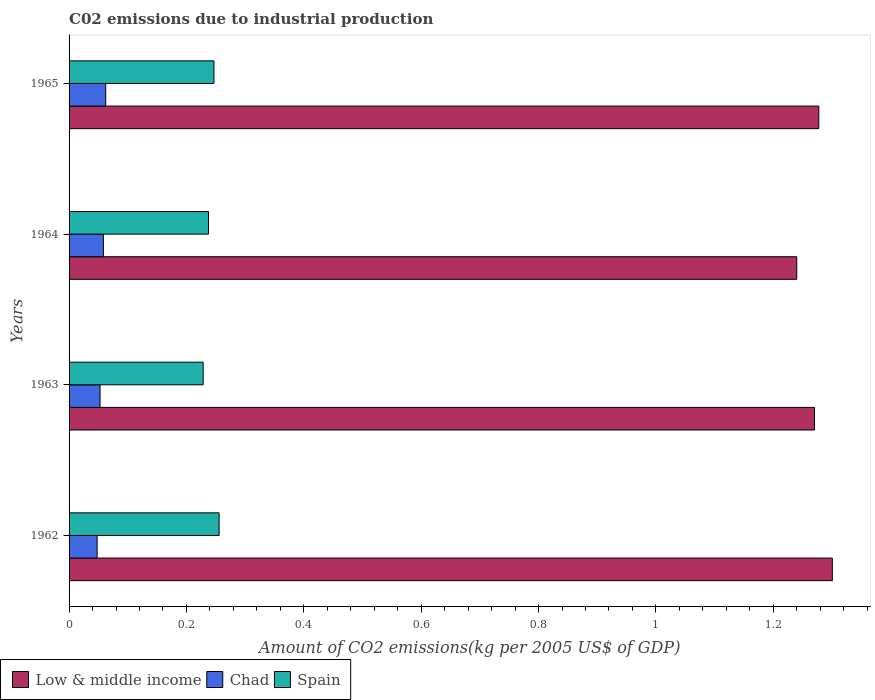How many groups of bars are there?
Offer a terse response. 4. Are the number of bars on each tick of the Y-axis equal?
Ensure brevity in your answer.  Yes. How many bars are there on the 3rd tick from the top?
Provide a short and direct response. 3. In how many cases, is the number of bars for a given year not equal to the number of legend labels?
Provide a short and direct response. 0. What is the amount of CO2 emitted due to industrial production in Chad in 1962?
Your answer should be compact. 0.05. Across all years, what is the maximum amount of CO2 emitted due to industrial production in Spain?
Provide a short and direct response. 0.26. Across all years, what is the minimum amount of CO2 emitted due to industrial production in Chad?
Provide a short and direct response. 0.05. In which year was the amount of CO2 emitted due to industrial production in Chad maximum?
Ensure brevity in your answer.  1965. In which year was the amount of CO2 emitted due to industrial production in Low & middle income minimum?
Offer a very short reply. 1964. What is the total amount of CO2 emitted due to industrial production in Low & middle income in the graph?
Ensure brevity in your answer.  5.09. What is the difference between the amount of CO2 emitted due to industrial production in Low & middle income in 1962 and that in 1963?
Your response must be concise. 0.03. What is the difference between the amount of CO2 emitted due to industrial production in Spain in 1964 and the amount of CO2 emitted due to industrial production in Low & middle income in 1963?
Your response must be concise. -1.03. What is the average amount of CO2 emitted due to industrial production in Low & middle income per year?
Offer a terse response. 1.27. In the year 1965, what is the difference between the amount of CO2 emitted due to industrial production in Low & middle income and amount of CO2 emitted due to industrial production in Spain?
Provide a succinct answer. 1.03. In how many years, is the amount of CO2 emitted due to industrial production in Chad greater than 1.2000000000000002 kg?
Provide a succinct answer. 0. What is the ratio of the amount of CO2 emitted due to industrial production in Low & middle income in 1963 to that in 1964?
Ensure brevity in your answer.  1.02. Is the amount of CO2 emitted due to industrial production in Spain in 1963 less than that in 1964?
Your answer should be very brief. Yes. Is the difference between the amount of CO2 emitted due to industrial production in Low & middle income in 1962 and 1964 greater than the difference between the amount of CO2 emitted due to industrial production in Spain in 1962 and 1964?
Offer a very short reply. Yes. What is the difference between the highest and the second highest amount of CO2 emitted due to industrial production in Chad?
Provide a succinct answer. 0. What is the difference between the highest and the lowest amount of CO2 emitted due to industrial production in Low & middle income?
Ensure brevity in your answer.  0.06. What does the 2nd bar from the top in 1964 represents?
Offer a terse response. Chad. Is it the case that in every year, the sum of the amount of CO2 emitted due to industrial production in Chad and amount of CO2 emitted due to industrial production in Spain is greater than the amount of CO2 emitted due to industrial production in Low & middle income?
Your answer should be very brief. No. Are the values on the major ticks of X-axis written in scientific E-notation?
Provide a short and direct response. No. Does the graph contain any zero values?
Your answer should be compact. No. Where does the legend appear in the graph?
Your answer should be very brief. Bottom left. How many legend labels are there?
Ensure brevity in your answer.  3. How are the legend labels stacked?
Your response must be concise. Horizontal. What is the title of the graph?
Provide a short and direct response. C02 emissions due to industrial production. What is the label or title of the X-axis?
Your answer should be very brief. Amount of CO2 emissions(kg per 2005 US$ of GDP). What is the Amount of CO2 emissions(kg per 2005 US$ of GDP) of Low & middle income in 1962?
Offer a very short reply. 1.3. What is the Amount of CO2 emissions(kg per 2005 US$ of GDP) in Chad in 1962?
Your answer should be compact. 0.05. What is the Amount of CO2 emissions(kg per 2005 US$ of GDP) of Spain in 1962?
Offer a terse response. 0.26. What is the Amount of CO2 emissions(kg per 2005 US$ of GDP) in Low & middle income in 1963?
Keep it short and to the point. 1.27. What is the Amount of CO2 emissions(kg per 2005 US$ of GDP) in Chad in 1963?
Keep it short and to the point. 0.05. What is the Amount of CO2 emissions(kg per 2005 US$ of GDP) in Spain in 1963?
Your answer should be very brief. 0.23. What is the Amount of CO2 emissions(kg per 2005 US$ of GDP) in Low & middle income in 1964?
Offer a very short reply. 1.24. What is the Amount of CO2 emissions(kg per 2005 US$ of GDP) in Chad in 1964?
Offer a very short reply. 0.06. What is the Amount of CO2 emissions(kg per 2005 US$ of GDP) in Spain in 1964?
Your answer should be very brief. 0.24. What is the Amount of CO2 emissions(kg per 2005 US$ of GDP) in Low & middle income in 1965?
Your answer should be very brief. 1.28. What is the Amount of CO2 emissions(kg per 2005 US$ of GDP) of Chad in 1965?
Your answer should be compact. 0.06. What is the Amount of CO2 emissions(kg per 2005 US$ of GDP) in Spain in 1965?
Keep it short and to the point. 0.25. Across all years, what is the maximum Amount of CO2 emissions(kg per 2005 US$ of GDP) in Low & middle income?
Provide a succinct answer. 1.3. Across all years, what is the maximum Amount of CO2 emissions(kg per 2005 US$ of GDP) of Chad?
Keep it short and to the point. 0.06. Across all years, what is the maximum Amount of CO2 emissions(kg per 2005 US$ of GDP) in Spain?
Your response must be concise. 0.26. Across all years, what is the minimum Amount of CO2 emissions(kg per 2005 US$ of GDP) in Low & middle income?
Offer a terse response. 1.24. Across all years, what is the minimum Amount of CO2 emissions(kg per 2005 US$ of GDP) in Chad?
Make the answer very short. 0.05. Across all years, what is the minimum Amount of CO2 emissions(kg per 2005 US$ of GDP) in Spain?
Make the answer very short. 0.23. What is the total Amount of CO2 emissions(kg per 2005 US$ of GDP) of Low & middle income in the graph?
Make the answer very short. 5.09. What is the total Amount of CO2 emissions(kg per 2005 US$ of GDP) of Chad in the graph?
Offer a very short reply. 0.22. What is the total Amount of CO2 emissions(kg per 2005 US$ of GDP) in Spain in the graph?
Provide a succinct answer. 0.97. What is the difference between the Amount of CO2 emissions(kg per 2005 US$ of GDP) in Low & middle income in 1962 and that in 1963?
Provide a short and direct response. 0.03. What is the difference between the Amount of CO2 emissions(kg per 2005 US$ of GDP) in Chad in 1962 and that in 1963?
Ensure brevity in your answer.  -0.01. What is the difference between the Amount of CO2 emissions(kg per 2005 US$ of GDP) of Spain in 1962 and that in 1963?
Make the answer very short. 0.03. What is the difference between the Amount of CO2 emissions(kg per 2005 US$ of GDP) of Low & middle income in 1962 and that in 1964?
Keep it short and to the point. 0.06. What is the difference between the Amount of CO2 emissions(kg per 2005 US$ of GDP) of Chad in 1962 and that in 1964?
Make the answer very short. -0.01. What is the difference between the Amount of CO2 emissions(kg per 2005 US$ of GDP) in Spain in 1962 and that in 1964?
Make the answer very short. 0.02. What is the difference between the Amount of CO2 emissions(kg per 2005 US$ of GDP) of Low & middle income in 1962 and that in 1965?
Give a very brief answer. 0.02. What is the difference between the Amount of CO2 emissions(kg per 2005 US$ of GDP) of Chad in 1962 and that in 1965?
Give a very brief answer. -0.01. What is the difference between the Amount of CO2 emissions(kg per 2005 US$ of GDP) of Spain in 1962 and that in 1965?
Your answer should be very brief. 0.01. What is the difference between the Amount of CO2 emissions(kg per 2005 US$ of GDP) of Low & middle income in 1963 and that in 1964?
Your answer should be very brief. 0.03. What is the difference between the Amount of CO2 emissions(kg per 2005 US$ of GDP) of Chad in 1963 and that in 1964?
Provide a short and direct response. -0.01. What is the difference between the Amount of CO2 emissions(kg per 2005 US$ of GDP) of Spain in 1963 and that in 1964?
Provide a succinct answer. -0.01. What is the difference between the Amount of CO2 emissions(kg per 2005 US$ of GDP) in Low & middle income in 1963 and that in 1965?
Ensure brevity in your answer.  -0.01. What is the difference between the Amount of CO2 emissions(kg per 2005 US$ of GDP) of Chad in 1963 and that in 1965?
Your answer should be very brief. -0.01. What is the difference between the Amount of CO2 emissions(kg per 2005 US$ of GDP) in Spain in 1963 and that in 1965?
Provide a short and direct response. -0.02. What is the difference between the Amount of CO2 emissions(kg per 2005 US$ of GDP) in Low & middle income in 1964 and that in 1965?
Your answer should be compact. -0.04. What is the difference between the Amount of CO2 emissions(kg per 2005 US$ of GDP) in Chad in 1964 and that in 1965?
Make the answer very short. -0. What is the difference between the Amount of CO2 emissions(kg per 2005 US$ of GDP) in Spain in 1964 and that in 1965?
Make the answer very short. -0.01. What is the difference between the Amount of CO2 emissions(kg per 2005 US$ of GDP) of Low & middle income in 1962 and the Amount of CO2 emissions(kg per 2005 US$ of GDP) of Chad in 1963?
Keep it short and to the point. 1.25. What is the difference between the Amount of CO2 emissions(kg per 2005 US$ of GDP) in Low & middle income in 1962 and the Amount of CO2 emissions(kg per 2005 US$ of GDP) in Spain in 1963?
Your answer should be compact. 1.07. What is the difference between the Amount of CO2 emissions(kg per 2005 US$ of GDP) of Chad in 1962 and the Amount of CO2 emissions(kg per 2005 US$ of GDP) of Spain in 1963?
Offer a very short reply. -0.18. What is the difference between the Amount of CO2 emissions(kg per 2005 US$ of GDP) of Low & middle income in 1962 and the Amount of CO2 emissions(kg per 2005 US$ of GDP) of Chad in 1964?
Ensure brevity in your answer.  1.24. What is the difference between the Amount of CO2 emissions(kg per 2005 US$ of GDP) in Low & middle income in 1962 and the Amount of CO2 emissions(kg per 2005 US$ of GDP) in Spain in 1964?
Your answer should be compact. 1.06. What is the difference between the Amount of CO2 emissions(kg per 2005 US$ of GDP) in Chad in 1962 and the Amount of CO2 emissions(kg per 2005 US$ of GDP) in Spain in 1964?
Offer a very short reply. -0.19. What is the difference between the Amount of CO2 emissions(kg per 2005 US$ of GDP) in Low & middle income in 1962 and the Amount of CO2 emissions(kg per 2005 US$ of GDP) in Chad in 1965?
Ensure brevity in your answer.  1.24. What is the difference between the Amount of CO2 emissions(kg per 2005 US$ of GDP) of Low & middle income in 1962 and the Amount of CO2 emissions(kg per 2005 US$ of GDP) of Spain in 1965?
Offer a very short reply. 1.05. What is the difference between the Amount of CO2 emissions(kg per 2005 US$ of GDP) in Chad in 1962 and the Amount of CO2 emissions(kg per 2005 US$ of GDP) in Spain in 1965?
Your answer should be compact. -0.2. What is the difference between the Amount of CO2 emissions(kg per 2005 US$ of GDP) in Low & middle income in 1963 and the Amount of CO2 emissions(kg per 2005 US$ of GDP) in Chad in 1964?
Provide a succinct answer. 1.21. What is the difference between the Amount of CO2 emissions(kg per 2005 US$ of GDP) in Low & middle income in 1963 and the Amount of CO2 emissions(kg per 2005 US$ of GDP) in Spain in 1964?
Offer a terse response. 1.03. What is the difference between the Amount of CO2 emissions(kg per 2005 US$ of GDP) of Chad in 1963 and the Amount of CO2 emissions(kg per 2005 US$ of GDP) of Spain in 1964?
Keep it short and to the point. -0.18. What is the difference between the Amount of CO2 emissions(kg per 2005 US$ of GDP) in Low & middle income in 1963 and the Amount of CO2 emissions(kg per 2005 US$ of GDP) in Chad in 1965?
Keep it short and to the point. 1.21. What is the difference between the Amount of CO2 emissions(kg per 2005 US$ of GDP) in Low & middle income in 1963 and the Amount of CO2 emissions(kg per 2005 US$ of GDP) in Spain in 1965?
Provide a short and direct response. 1.02. What is the difference between the Amount of CO2 emissions(kg per 2005 US$ of GDP) in Chad in 1963 and the Amount of CO2 emissions(kg per 2005 US$ of GDP) in Spain in 1965?
Offer a terse response. -0.19. What is the difference between the Amount of CO2 emissions(kg per 2005 US$ of GDP) in Low & middle income in 1964 and the Amount of CO2 emissions(kg per 2005 US$ of GDP) in Chad in 1965?
Ensure brevity in your answer.  1.18. What is the difference between the Amount of CO2 emissions(kg per 2005 US$ of GDP) of Chad in 1964 and the Amount of CO2 emissions(kg per 2005 US$ of GDP) of Spain in 1965?
Keep it short and to the point. -0.19. What is the average Amount of CO2 emissions(kg per 2005 US$ of GDP) of Low & middle income per year?
Provide a succinct answer. 1.27. What is the average Amount of CO2 emissions(kg per 2005 US$ of GDP) in Chad per year?
Keep it short and to the point. 0.06. What is the average Amount of CO2 emissions(kg per 2005 US$ of GDP) of Spain per year?
Keep it short and to the point. 0.24. In the year 1962, what is the difference between the Amount of CO2 emissions(kg per 2005 US$ of GDP) of Low & middle income and Amount of CO2 emissions(kg per 2005 US$ of GDP) of Chad?
Offer a very short reply. 1.25. In the year 1962, what is the difference between the Amount of CO2 emissions(kg per 2005 US$ of GDP) in Low & middle income and Amount of CO2 emissions(kg per 2005 US$ of GDP) in Spain?
Your answer should be very brief. 1.04. In the year 1962, what is the difference between the Amount of CO2 emissions(kg per 2005 US$ of GDP) in Chad and Amount of CO2 emissions(kg per 2005 US$ of GDP) in Spain?
Offer a very short reply. -0.21. In the year 1963, what is the difference between the Amount of CO2 emissions(kg per 2005 US$ of GDP) of Low & middle income and Amount of CO2 emissions(kg per 2005 US$ of GDP) of Chad?
Give a very brief answer. 1.22. In the year 1963, what is the difference between the Amount of CO2 emissions(kg per 2005 US$ of GDP) in Low & middle income and Amount of CO2 emissions(kg per 2005 US$ of GDP) in Spain?
Provide a short and direct response. 1.04. In the year 1963, what is the difference between the Amount of CO2 emissions(kg per 2005 US$ of GDP) of Chad and Amount of CO2 emissions(kg per 2005 US$ of GDP) of Spain?
Make the answer very short. -0.18. In the year 1964, what is the difference between the Amount of CO2 emissions(kg per 2005 US$ of GDP) of Low & middle income and Amount of CO2 emissions(kg per 2005 US$ of GDP) of Chad?
Your answer should be very brief. 1.18. In the year 1964, what is the difference between the Amount of CO2 emissions(kg per 2005 US$ of GDP) in Low & middle income and Amount of CO2 emissions(kg per 2005 US$ of GDP) in Spain?
Offer a terse response. 1. In the year 1964, what is the difference between the Amount of CO2 emissions(kg per 2005 US$ of GDP) in Chad and Amount of CO2 emissions(kg per 2005 US$ of GDP) in Spain?
Give a very brief answer. -0.18. In the year 1965, what is the difference between the Amount of CO2 emissions(kg per 2005 US$ of GDP) in Low & middle income and Amount of CO2 emissions(kg per 2005 US$ of GDP) in Chad?
Give a very brief answer. 1.22. In the year 1965, what is the difference between the Amount of CO2 emissions(kg per 2005 US$ of GDP) in Low & middle income and Amount of CO2 emissions(kg per 2005 US$ of GDP) in Spain?
Ensure brevity in your answer.  1.03. In the year 1965, what is the difference between the Amount of CO2 emissions(kg per 2005 US$ of GDP) in Chad and Amount of CO2 emissions(kg per 2005 US$ of GDP) in Spain?
Your response must be concise. -0.18. What is the ratio of the Amount of CO2 emissions(kg per 2005 US$ of GDP) of Low & middle income in 1962 to that in 1963?
Your response must be concise. 1.02. What is the ratio of the Amount of CO2 emissions(kg per 2005 US$ of GDP) in Chad in 1962 to that in 1963?
Ensure brevity in your answer.  0.91. What is the ratio of the Amount of CO2 emissions(kg per 2005 US$ of GDP) in Spain in 1962 to that in 1963?
Provide a succinct answer. 1.12. What is the ratio of the Amount of CO2 emissions(kg per 2005 US$ of GDP) in Low & middle income in 1962 to that in 1964?
Make the answer very short. 1.05. What is the ratio of the Amount of CO2 emissions(kg per 2005 US$ of GDP) of Chad in 1962 to that in 1964?
Offer a very short reply. 0.82. What is the ratio of the Amount of CO2 emissions(kg per 2005 US$ of GDP) of Spain in 1962 to that in 1964?
Give a very brief answer. 1.08. What is the ratio of the Amount of CO2 emissions(kg per 2005 US$ of GDP) in Low & middle income in 1962 to that in 1965?
Make the answer very short. 1.02. What is the ratio of the Amount of CO2 emissions(kg per 2005 US$ of GDP) in Chad in 1962 to that in 1965?
Provide a short and direct response. 0.77. What is the ratio of the Amount of CO2 emissions(kg per 2005 US$ of GDP) of Spain in 1962 to that in 1965?
Keep it short and to the point. 1.04. What is the ratio of the Amount of CO2 emissions(kg per 2005 US$ of GDP) in Low & middle income in 1963 to that in 1964?
Your answer should be compact. 1.02. What is the ratio of the Amount of CO2 emissions(kg per 2005 US$ of GDP) of Chad in 1963 to that in 1964?
Offer a terse response. 0.9. What is the ratio of the Amount of CO2 emissions(kg per 2005 US$ of GDP) of Spain in 1963 to that in 1964?
Provide a succinct answer. 0.96. What is the ratio of the Amount of CO2 emissions(kg per 2005 US$ of GDP) in Low & middle income in 1963 to that in 1965?
Your answer should be compact. 0.99. What is the ratio of the Amount of CO2 emissions(kg per 2005 US$ of GDP) in Chad in 1963 to that in 1965?
Your response must be concise. 0.85. What is the ratio of the Amount of CO2 emissions(kg per 2005 US$ of GDP) in Spain in 1963 to that in 1965?
Offer a terse response. 0.93. What is the ratio of the Amount of CO2 emissions(kg per 2005 US$ of GDP) of Low & middle income in 1964 to that in 1965?
Offer a terse response. 0.97. What is the ratio of the Amount of CO2 emissions(kg per 2005 US$ of GDP) in Chad in 1964 to that in 1965?
Provide a short and direct response. 0.94. What is the ratio of the Amount of CO2 emissions(kg per 2005 US$ of GDP) in Spain in 1964 to that in 1965?
Ensure brevity in your answer.  0.96. What is the difference between the highest and the second highest Amount of CO2 emissions(kg per 2005 US$ of GDP) in Low & middle income?
Give a very brief answer. 0.02. What is the difference between the highest and the second highest Amount of CO2 emissions(kg per 2005 US$ of GDP) of Chad?
Your answer should be compact. 0. What is the difference between the highest and the second highest Amount of CO2 emissions(kg per 2005 US$ of GDP) of Spain?
Your answer should be very brief. 0.01. What is the difference between the highest and the lowest Amount of CO2 emissions(kg per 2005 US$ of GDP) of Low & middle income?
Give a very brief answer. 0.06. What is the difference between the highest and the lowest Amount of CO2 emissions(kg per 2005 US$ of GDP) of Chad?
Offer a very short reply. 0.01. What is the difference between the highest and the lowest Amount of CO2 emissions(kg per 2005 US$ of GDP) in Spain?
Your answer should be very brief. 0.03. 